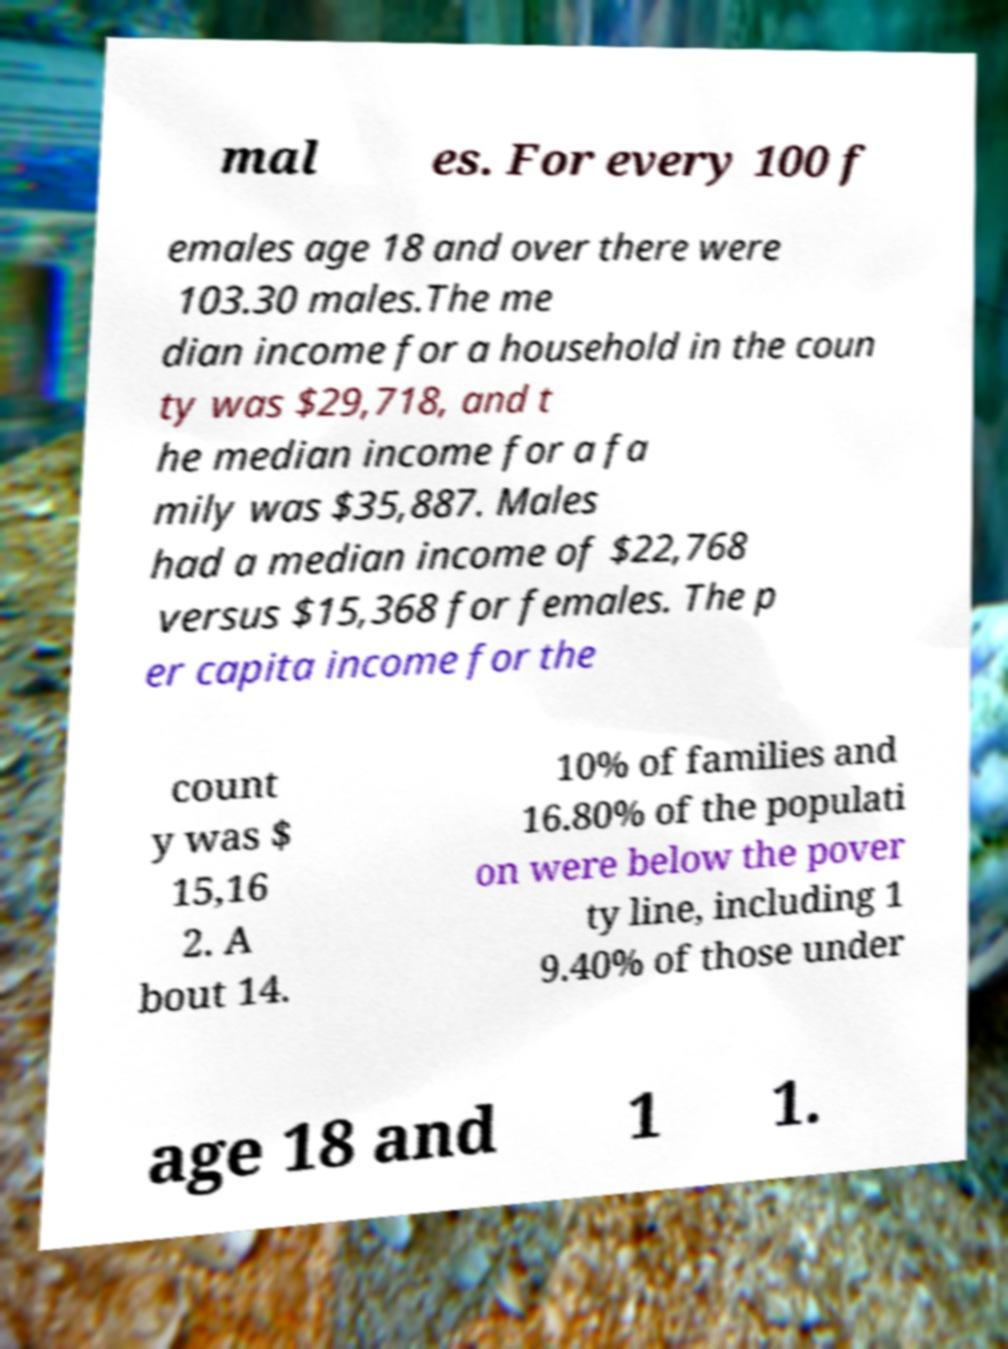Please read and relay the text visible in this image. What does it say? mal es. For every 100 f emales age 18 and over there were 103.30 males.The me dian income for a household in the coun ty was $29,718, and t he median income for a fa mily was $35,887. Males had a median income of $22,768 versus $15,368 for females. The p er capita income for the count y was $ 15,16 2. A bout 14. 10% of families and 16.80% of the populati on were below the pover ty line, including 1 9.40% of those under age 18 and 1 1. 